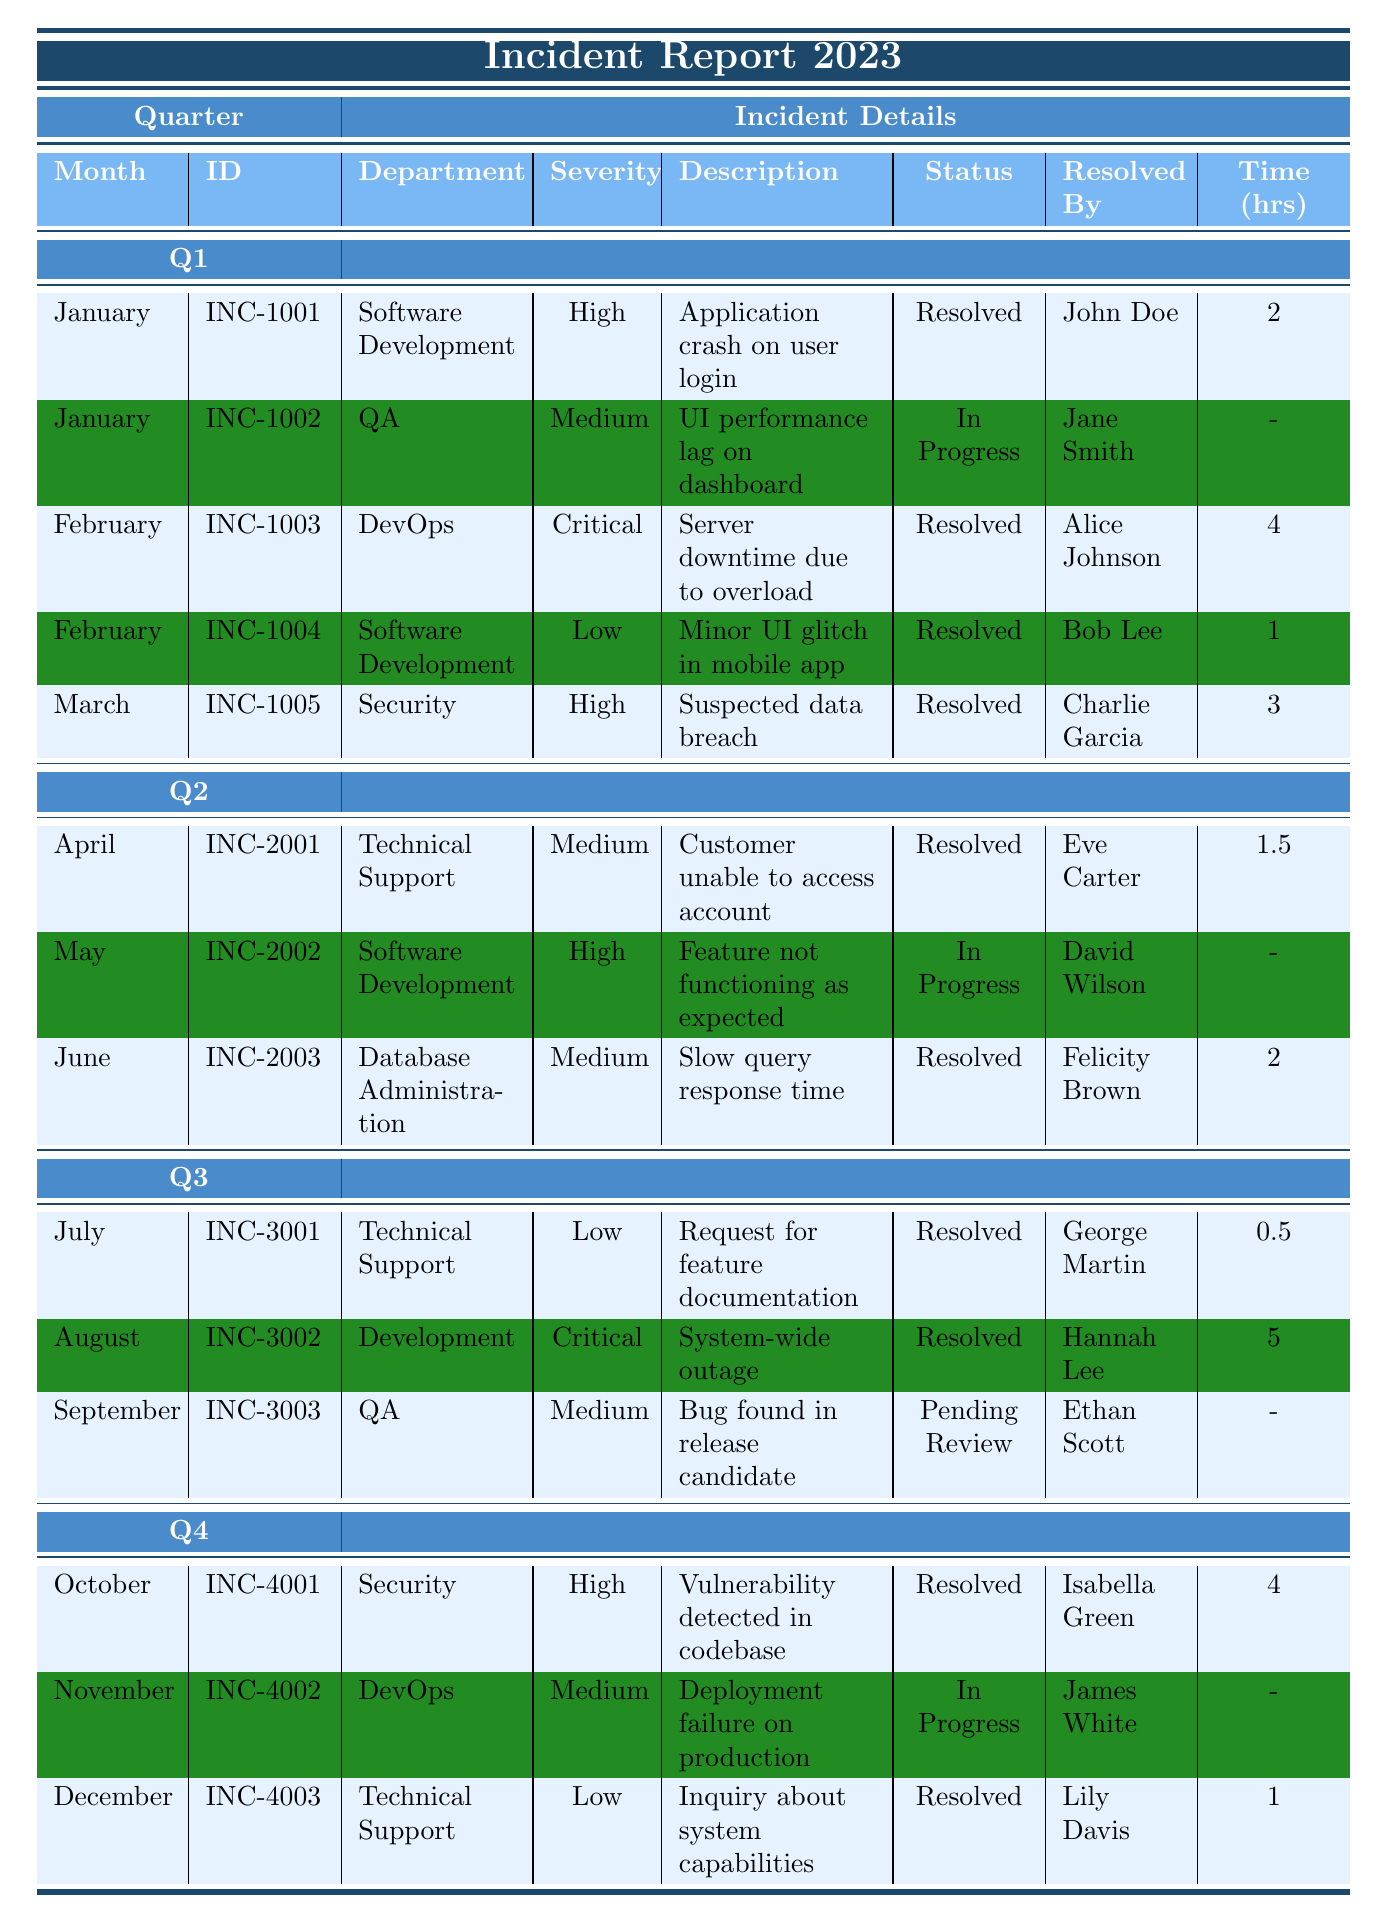What is the total number of incidents reported in Q1? In Q1, there are incidents from January (2), February (2), and March (1), summing up to 2 + 2 + 1 = 5 incidents in total.
Answer: 5 What incident was reported by the department with the highest severity in Q2? In Q2, the highest severity reported is "High" for the incident in May (INC-2002), which is "Feature not functioning as expected."
Answer: INC-2002 How many incidents are currently in progress? In the table, the incidents with the status "In Progress" are INC-1002, INC-2002, and INC-4002; thus 3 incidents are currently in progress.
Answer: 3 What is the average resolution time for resolved incidents in Q3? The resolved incidents in Q3 are for July (0.5 hours), August (5 hours), and there is one unresolved incident (INC-3003). So, the average is (0.5 + 5) / 2 = 2.75 hours.
Answer: 2.75 hours Which department has the most incidents that were resolved? Counting resolved incidents, Software Development (4), Technical Support (2), QA (2), and others have fewer; thus Software Development has the most incidents resolved with a total of 4.
Answer: Software Development Which month had the highest number of incidents reported? January and February each had 2 incidents, but for March, there is only 1; thus the months with the highest number of incidents are January and February with 2 each.
Answer: January and February Is there any incident that was reported but not resolved by the end of the year? Yes, there are incidents in the table labeled as "In Progress," indicating they were not resolved, specifically INC-1002, INC-2002, and INC-4002.
Answer: Yes What is the percentage of resolved incidents out of the total incidents reported for the year? There are 15 total incidents reported in the table, and 11 of those are marked as resolved, resulting in a percentage of (11/15) * 100 = 73.33%.
Answer: 73.33% Which incident had the longest resolution time? From the resolved incidents, the incident in August (INC-3002) had the longest resolution time of 5 hours.
Answer: INC-3002 Was there ever an incident in 2023 that was marked as "Pending Review"? Yes, the incident in September (INC-3003) is marked as "Pending Review".
Answer: Yes 